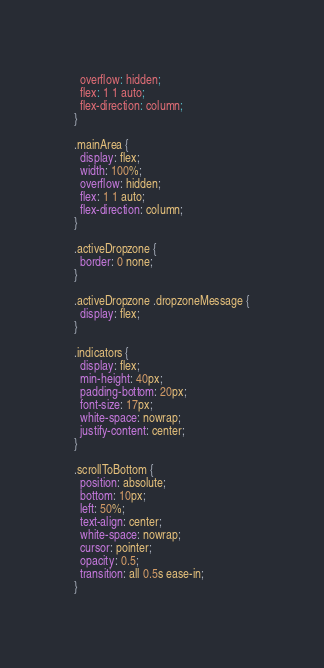Convert code to text. <code><loc_0><loc_0><loc_500><loc_500><_CSS_>  overflow: hidden;
  flex: 1 1 auto;
  flex-direction: column;
}

.mainArea {
  display: flex;
  width: 100%;
  overflow: hidden;
  flex: 1 1 auto;
  flex-direction: column;
}

.activeDropzone {
  border: 0 none;
}

.activeDropzone .dropzoneMessage {
  display: flex;
}

.indicators {
  display: flex;
  min-height: 40px;
  padding-bottom: 20px;
  font-size: 17px;
  white-space: nowrap;
  justify-content: center;
}

.scrollToBottom {
  position: absolute;
  bottom: 10px;
  left: 50%;
  text-align: center;
  white-space: nowrap;
  cursor: pointer;
  opacity: 0.5;
  transition: all 0.5s ease-in;
}
</code> 